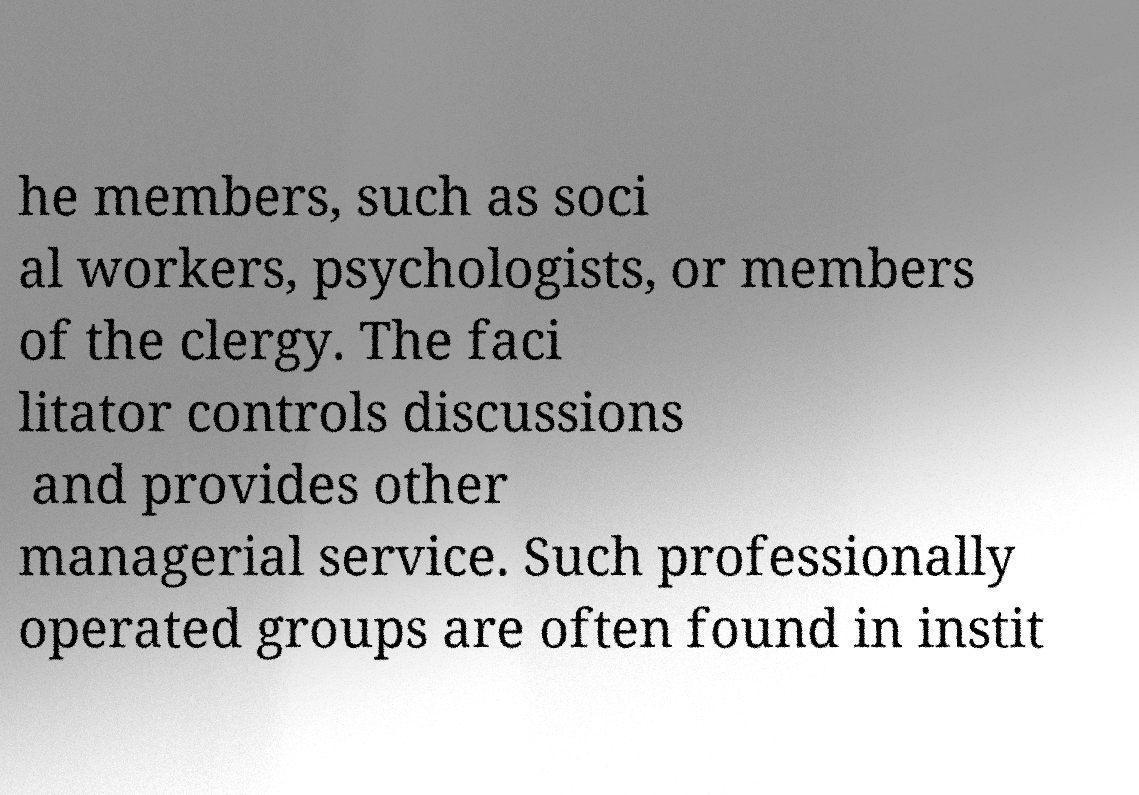Can you accurately transcribe the text from the provided image for me? he members, such as soci al workers, psychologists, or members of the clergy. The faci litator controls discussions and provides other managerial service. Such professionally operated groups are often found in instit 